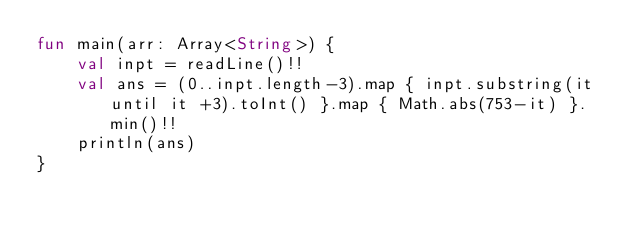Convert code to text. <code><loc_0><loc_0><loc_500><loc_500><_Kotlin_>fun main(arr: Array<String>) {
    val inpt = readLine()!!
    val ans = (0..inpt.length-3).map { inpt.substring(it until it +3).toInt() }.map { Math.abs(753-it) }.min()!!
    println(ans)
}

</code> 